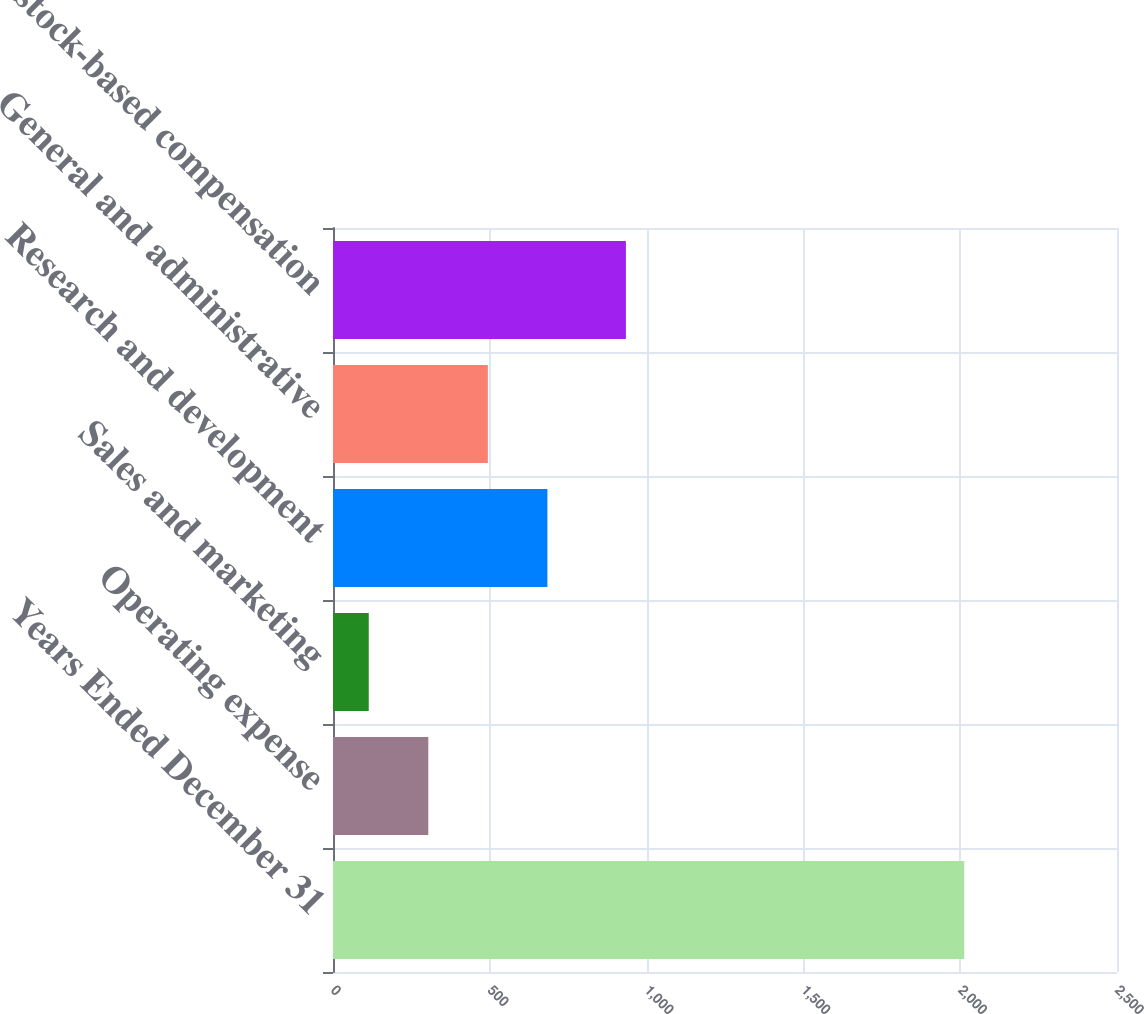Convert chart to OTSL. <chart><loc_0><loc_0><loc_500><loc_500><bar_chart><fcel>Years Ended December 31<fcel>Operating expense<fcel>Sales and marketing<fcel>Research and development<fcel>General and administrative<fcel>Total stock-based compensation<nl><fcel>2013<fcel>303.9<fcel>114<fcel>683.7<fcel>493.8<fcel>934<nl></chart> 